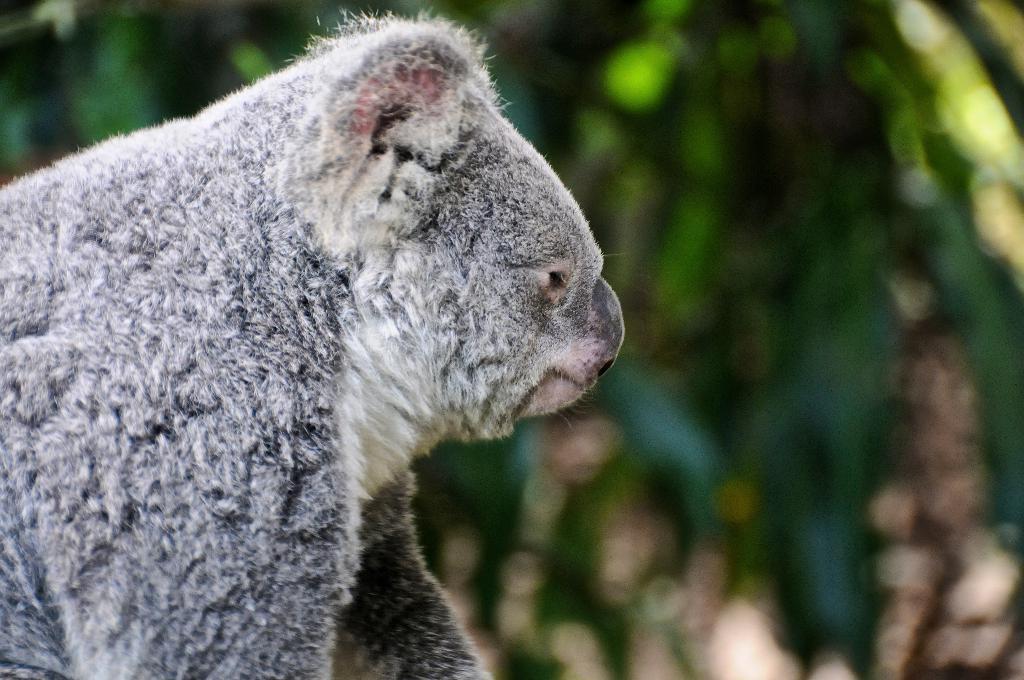Could you give a brief overview of what you see in this image? In the picture I can see an animal. The background of the image is blurred. 